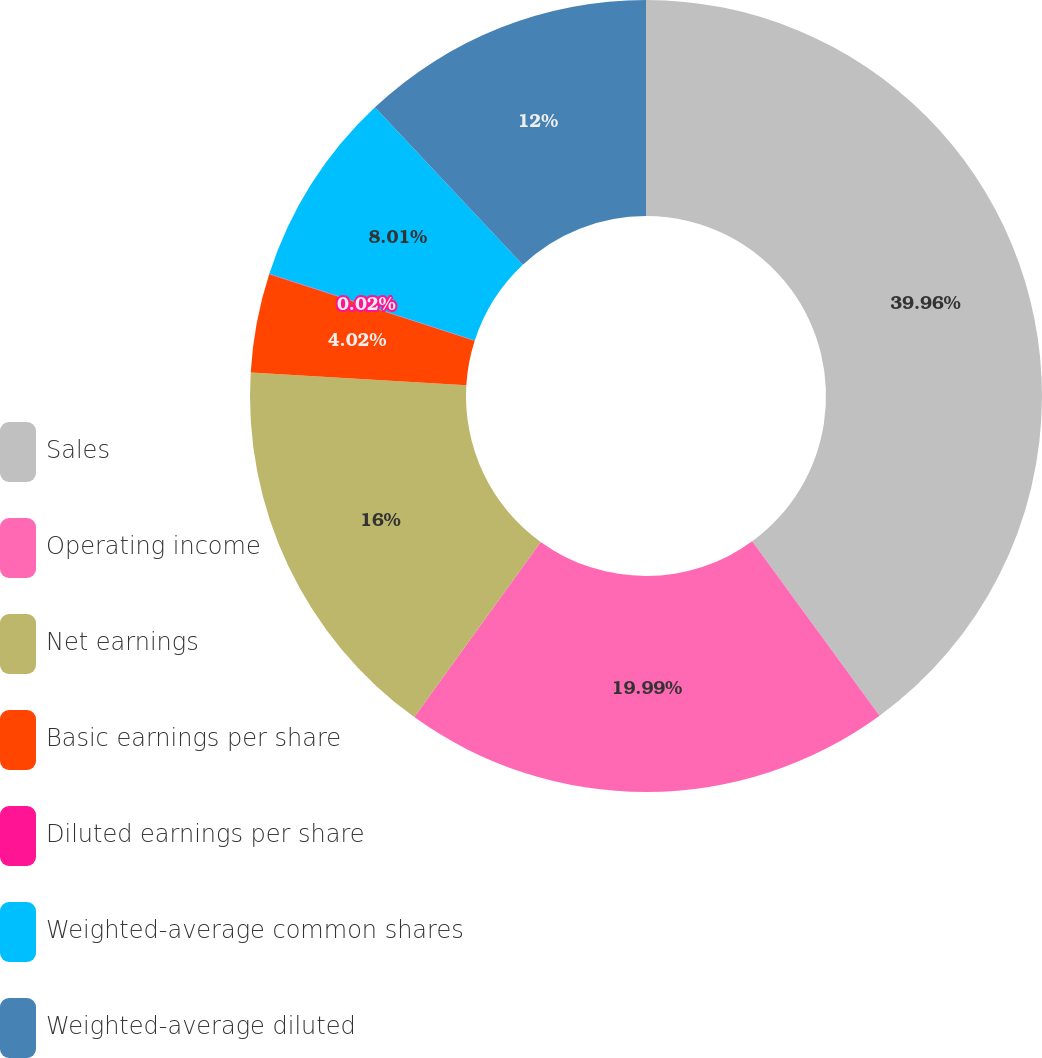Convert chart to OTSL. <chart><loc_0><loc_0><loc_500><loc_500><pie_chart><fcel>Sales<fcel>Operating income<fcel>Net earnings<fcel>Basic earnings per share<fcel>Diluted earnings per share<fcel>Weighted-average common shares<fcel>Weighted-average diluted<nl><fcel>39.96%<fcel>19.99%<fcel>16.0%<fcel>4.02%<fcel>0.02%<fcel>8.01%<fcel>12.0%<nl></chart> 